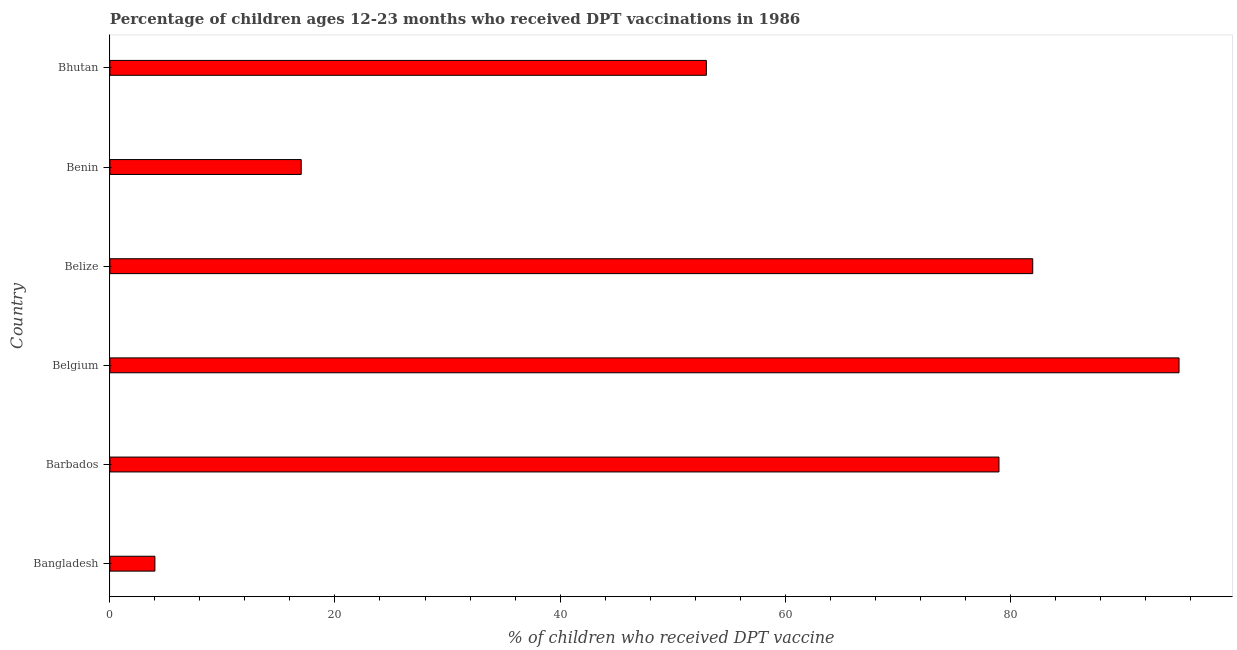What is the title of the graph?
Ensure brevity in your answer.  Percentage of children ages 12-23 months who received DPT vaccinations in 1986. What is the label or title of the X-axis?
Provide a succinct answer. % of children who received DPT vaccine. Across all countries, what is the maximum percentage of children who received dpt vaccine?
Offer a very short reply. 95. Across all countries, what is the minimum percentage of children who received dpt vaccine?
Make the answer very short. 4. In which country was the percentage of children who received dpt vaccine maximum?
Offer a very short reply. Belgium. In which country was the percentage of children who received dpt vaccine minimum?
Give a very brief answer. Bangladesh. What is the sum of the percentage of children who received dpt vaccine?
Your response must be concise. 330. What is the difference between the percentage of children who received dpt vaccine in Bangladesh and Belize?
Make the answer very short. -78. Is the difference between the percentage of children who received dpt vaccine in Bangladesh and Barbados greater than the difference between any two countries?
Make the answer very short. No. What is the difference between the highest and the second highest percentage of children who received dpt vaccine?
Offer a very short reply. 13. What is the difference between the highest and the lowest percentage of children who received dpt vaccine?
Offer a terse response. 91. In how many countries, is the percentage of children who received dpt vaccine greater than the average percentage of children who received dpt vaccine taken over all countries?
Your answer should be compact. 3. Are the values on the major ticks of X-axis written in scientific E-notation?
Offer a very short reply. No. What is the % of children who received DPT vaccine in Barbados?
Offer a very short reply. 79. What is the % of children who received DPT vaccine in Belize?
Your answer should be compact. 82. What is the % of children who received DPT vaccine in Benin?
Ensure brevity in your answer.  17. What is the difference between the % of children who received DPT vaccine in Bangladesh and Barbados?
Make the answer very short. -75. What is the difference between the % of children who received DPT vaccine in Bangladesh and Belgium?
Ensure brevity in your answer.  -91. What is the difference between the % of children who received DPT vaccine in Bangladesh and Belize?
Offer a very short reply. -78. What is the difference between the % of children who received DPT vaccine in Bangladesh and Benin?
Keep it short and to the point. -13. What is the difference between the % of children who received DPT vaccine in Bangladesh and Bhutan?
Make the answer very short. -49. What is the difference between the % of children who received DPT vaccine in Barbados and Belize?
Give a very brief answer. -3. What is the difference between the % of children who received DPT vaccine in Belgium and Benin?
Give a very brief answer. 78. What is the difference between the % of children who received DPT vaccine in Belgium and Bhutan?
Provide a short and direct response. 42. What is the difference between the % of children who received DPT vaccine in Belize and Bhutan?
Provide a short and direct response. 29. What is the difference between the % of children who received DPT vaccine in Benin and Bhutan?
Provide a short and direct response. -36. What is the ratio of the % of children who received DPT vaccine in Bangladesh to that in Barbados?
Your response must be concise. 0.05. What is the ratio of the % of children who received DPT vaccine in Bangladesh to that in Belgium?
Your answer should be very brief. 0.04. What is the ratio of the % of children who received DPT vaccine in Bangladesh to that in Belize?
Keep it short and to the point. 0.05. What is the ratio of the % of children who received DPT vaccine in Bangladesh to that in Benin?
Make the answer very short. 0.23. What is the ratio of the % of children who received DPT vaccine in Bangladesh to that in Bhutan?
Your answer should be very brief. 0.07. What is the ratio of the % of children who received DPT vaccine in Barbados to that in Belgium?
Your answer should be very brief. 0.83. What is the ratio of the % of children who received DPT vaccine in Barbados to that in Belize?
Your answer should be compact. 0.96. What is the ratio of the % of children who received DPT vaccine in Barbados to that in Benin?
Ensure brevity in your answer.  4.65. What is the ratio of the % of children who received DPT vaccine in Barbados to that in Bhutan?
Your response must be concise. 1.49. What is the ratio of the % of children who received DPT vaccine in Belgium to that in Belize?
Your answer should be very brief. 1.16. What is the ratio of the % of children who received DPT vaccine in Belgium to that in Benin?
Offer a very short reply. 5.59. What is the ratio of the % of children who received DPT vaccine in Belgium to that in Bhutan?
Offer a very short reply. 1.79. What is the ratio of the % of children who received DPT vaccine in Belize to that in Benin?
Keep it short and to the point. 4.82. What is the ratio of the % of children who received DPT vaccine in Belize to that in Bhutan?
Offer a very short reply. 1.55. What is the ratio of the % of children who received DPT vaccine in Benin to that in Bhutan?
Your answer should be very brief. 0.32. 